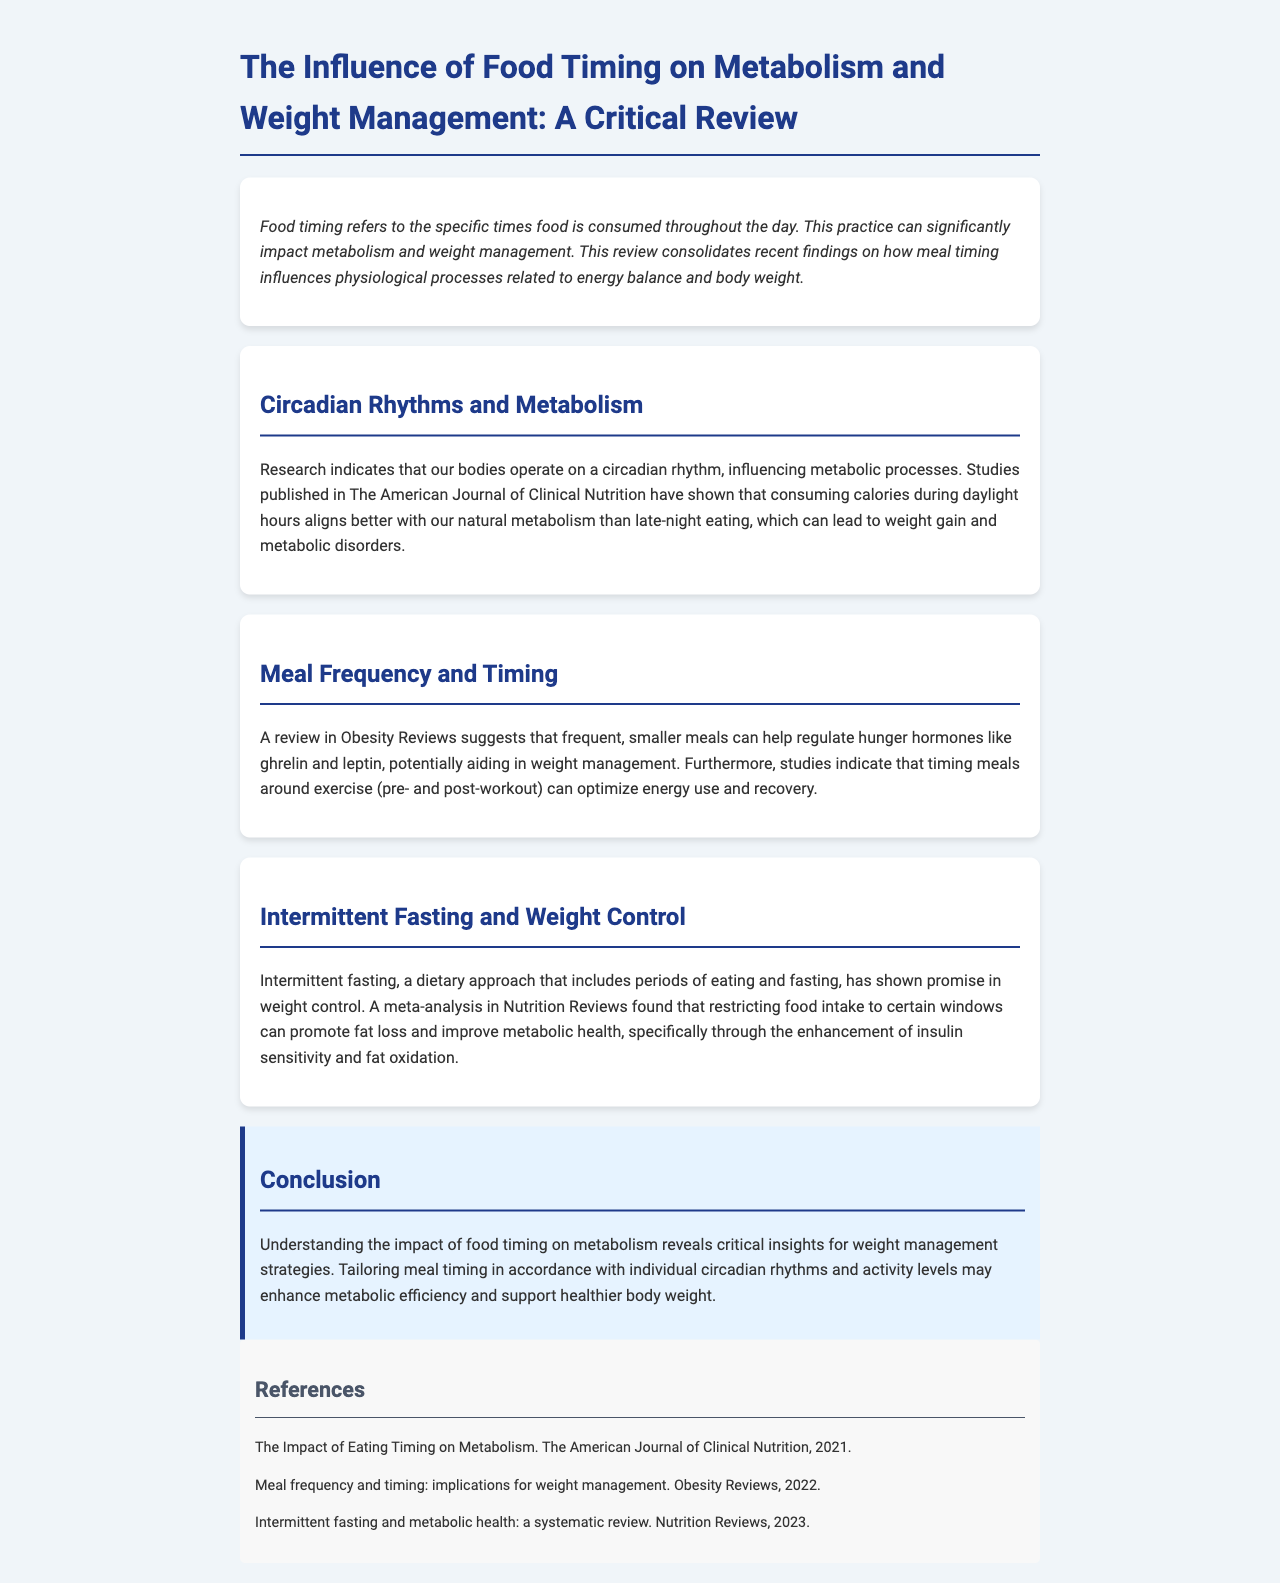What does food timing influence? Food timing refers to the specific times food is consumed throughout the day and can significantly impact metabolism and weight management.
Answer: Metabolism and weight management Which journal published research on circadian rhythms and metabolism? The American Journal of Clinical Nutrition published studies indicating the influence of circadian rhythms on metabolic processes.
Answer: The American Journal of Clinical Nutrition What dietary approach restricts food intake to certain windows? Intermittent fasting is a dietary approach that includes periods of eating and fasting, indicating it can promote fat loss and improve metabolic health.
Answer: Intermittent fasting What hormones do frequent meals help regulate? Frequent, smaller meals can help regulate hunger hormones such as ghrelin and leptin, contributing to weight management.
Answer: Ghrelin and leptin What is the main takeaway from the conclusion? The conclusion emphasizes tailoring meal timing according to individual circadian rhythms and activity levels to enhance metabolic efficiency.
Answer: Tailoring meal timing Which year was the systematic review on intermittent fasting published? The systematic review on intermittent fasting was published in 2023, focusing on its effects on metabolic health.
Answer: 2023 What type of meal timing is emphasized for optimizing energy use? Timing meals around exercise, specifically pre- and post-workout meals, is emphasized for optimizing energy use and recovery.
Answer: Around exercise Which review discusses meal frequency and timing implications? The review in Obesity Reviews discusses the implications of meal frequency and timing for weight management strategies.
Answer: Obesity Reviews What physiological effects can meal timing have? Meal timing can influence physiological processes related to energy balance and body weight, according to the reviewed findings.
Answer: Energy balance and body weight 